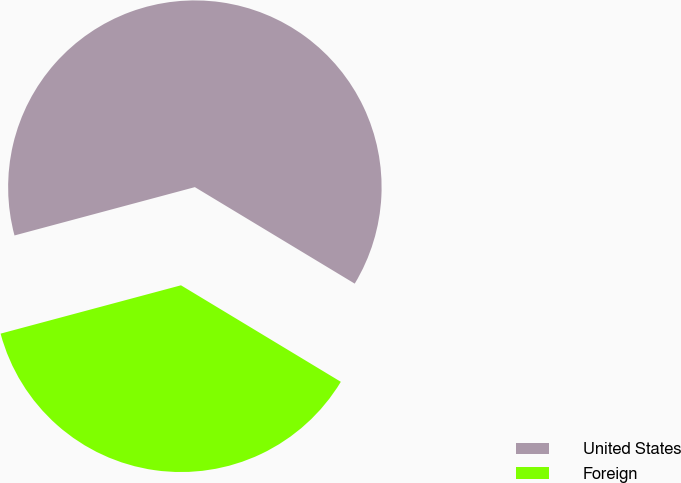Convert chart to OTSL. <chart><loc_0><loc_0><loc_500><loc_500><pie_chart><fcel>United States<fcel>Foreign<nl><fcel>62.81%<fcel>37.19%<nl></chart> 